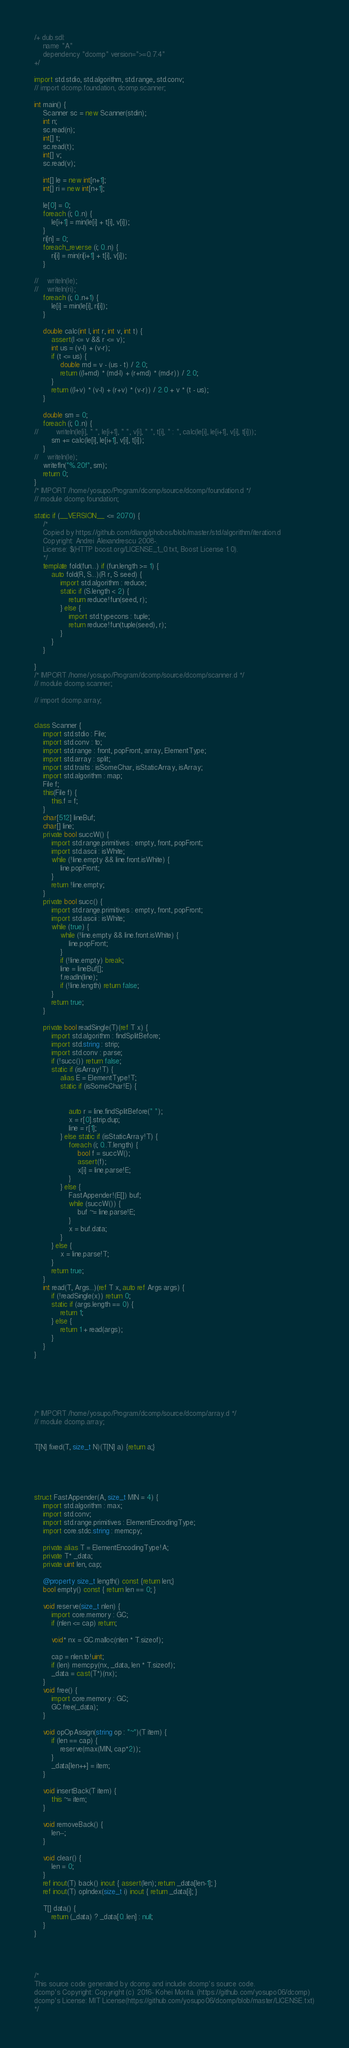<code> <loc_0><loc_0><loc_500><loc_500><_D_>/+ dub.sdl:
    name "A"
    dependency "dcomp" version=">=0.7.4"
+/

import std.stdio, std.algorithm, std.range, std.conv;
// import dcomp.foundation, dcomp.scanner;

int main() {
    Scanner sc = new Scanner(stdin);
    int n;
    sc.read(n);
    int[] t;
    sc.read(t);
    int[] v;
    sc.read(v);

    int[] le = new int[n+1];
    int[] ri = new int[n+1];

    le[0] = 0;
    foreach (i; 0..n) {
        le[i+1] = min(le[i] + t[i], v[i]);
    }
    ri[n] = 0;
    foreach_reverse (i; 0..n) {
        ri[i] = min(ri[i+1] + t[i], v[i]);
    }

//    writeln(le);
//    writeln(ri);
    foreach (i; 0..n+1) {
        le[i] = min(le[i], ri[i]);
    }

    double calc(int l, int r, int v, int t) {
        assert(l <= v && r <= v);
        int us = (v-l) + (v-r);
        if (t <= us) {
            double md = v - (us - t) / 2.0;
            return ((l+md) * (md-l) + (r+md) * (md-r)) / 2.0;
        }
        return ((l+v) * (v-l) + (r+v) * (v-r)) / 2.0 + v * (t - us);
    }

    double sm = 0;
    foreach (i; 0..n) {
//        writeln(le[i], " ", le[i+1], " ", v[i], " ", t[i], " : ", calc(le[i], le[i+1], v[i], t[i]));
        sm += calc(le[i], le[i+1], v[i], t[i]);
    }
//    writeln(le);
    writefln("%.20f", sm);
    return 0;
}
/* IMPORT /home/yosupo/Program/dcomp/source/dcomp/foundation.d */
// module dcomp.foundation;
 
static if (__VERSION__ <= 2070) {
    /*
    Copied by https://github.com/dlang/phobos/blob/master/std/algorithm/iteration.d
    Copyright: Andrei Alexandrescu 2008-.
    License: $(HTTP boost.org/LICENSE_1_0.txt, Boost License 1.0).
    */
    template fold(fun...) if (fun.length >= 1) {
        auto fold(R, S...)(R r, S seed) {
            import std.algorithm : reduce;
            static if (S.length < 2) {
                return reduce!fun(seed, r);
            } else {
                import std.typecons : tuple;
                return reduce!fun(tuple(seed), r);
            }
        }
    }
     
}
/* IMPORT /home/yosupo/Program/dcomp/source/dcomp/scanner.d */
// module dcomp.scanner;

// import dcomp.array;

 
class Scanner {
    import std.stdio : File;
    import std.conv : to;
    import std.range : front, popFront, array, ElementType;
    import std.array : split;
    import std.traits : isSomeChar, isStaticArray, isArray; 
    import std.algorithm : map;
    File f;
    this(File f) {
        this.f = f;
    }
    char[512] lineBuf;
    char[] line;
    private bool succW() {
        import std.range.primitives : empty, front, popFront;
        import std.ascii : isWhite;
        while (!line.empty && line.front.isWhite) {
            line.popFront;
        }
        return !line.empty;
    }
    private bool succ() {
        import std.range.primitives : empty, front, popFront;
        import std.ascii : isWhite;
        while (true) {
            while (!line.empty && line.front.isWhite) {
                line.popFront;
            }
            if (!line.empty) break;
            line = lineBuf[];
            f.readln(line);
            if (!line.length) return false;
        }
        return true;
    }

    private bool readSingle(T)(ref T x) {
        import std.algorithm : findSplitBefore;
        import std.string : strip;
        import std.conv : parse;
        if (!succ()) return false;
        static if (isArray!T) {
            alias E = ElementType!T;
            static if (isSomeChar!E) {
                 
                 
                auto r = line.findSplitBefore(" ");
                x = r[0].strip.dup;
                line = r[1];
            } else static if (isStaticArray!T) {
                foreach (i; 0..T.length) {
                    bool f = succW();
                    assert(f);
                    x[i] = line.parse!E;
                }
            } else {
                FastAppender!(E[]) buf;
                while (succW()) {
                    buf ~= line.parse!E;
                }
                x = buf.data;
            }
        } else {
            x = line.parse!T;
        }
        return true;
    }
    int read(T, Args...)(ref T x, auto ref Args args) {
        if (!readSingle(x)) return 0;
        static if (args.length == 0) {
            return 1;
        } else {
            return 1 + read(args);
        }
    }
}


 
 

 
/* IMPORT /home/yosupo/Program/dcomp/source/dcomp/array.d */
// module dcomp.array;

 
T[N] fixed(T, size_t N)(T[N] a) {return a;}

 
 

 
struct FastAppender(A, size_t MIN = 4) {
    import std.algorithm : max;
    import std.conv;
    import std.range.primitives : ElementEncodingType;
    import core.stdc.string : memcpy;

    private alias T = ElementEncodingType!A;
    private T* _data;
    private uint len, cap;
     
    @property size_t length() const {return len;}
    bool empty() const { return len == 0; }
     
    void reserve(size_t nlen) {
        import core.memory : GC;
        if (nlen <= cap) return;
        
        void* nx = GC.malloc(nlen * T.sizeof);

        cap = nlen.to!uint;
        if (len) memcpy(nx, _data, len * T.sizeof);
        _data = cast(T*)(nx);
    }
    void free() {
        import core.memory : GC;
        GC.free(_data);
    }
     
    void opOpAssign(string op : "~")(T item) {
        if (len == cap) {
            reserve(max(MIN, cap*2));
        }
        _data[len++] = item;
    }
     
    void insertBack(T item) {
        this ~= item;
    }
     
    void removeBack() {
        len--;
    }
     
    void clear() {
        len = 0;
    }
    ref inout(T) back() inout { assert(len); return _data[len-1]; }
    ref inout(T) opIndex(size_t i) inout { return _data[i]; }
     
    T[] data() {
        return (_data) ? _data[0..len] : null;
    }
}

 
 

/*
This source code generated by dcomp and include dcomp's source code.
dcomp's Copyright: Copyright (c) 2016- Kohei Morita. (https://github.com/yosupo06/dcomp)
dcomp's License: MIT License(https://github.com/yosupo06/dcomp/blob/master/LICENSE.txt)
*/
</code> 